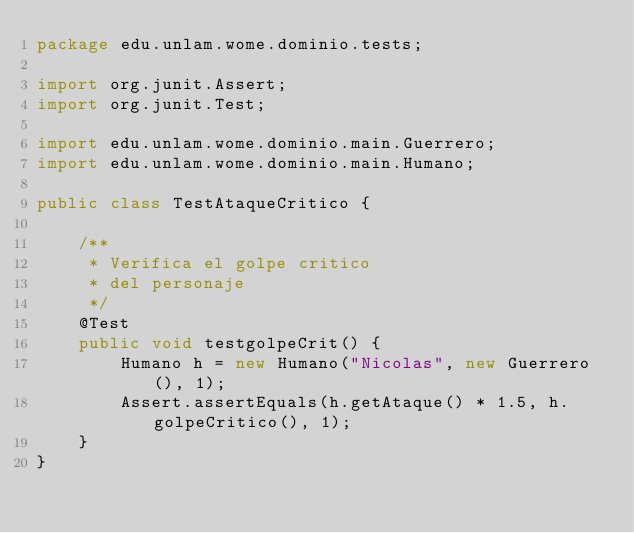<code> <loc_0><loc_0><loc_500><loc_500><_Java_>package edu.unlam.wome.dominio.tests;

import org.junit.Assert;
import org.junit.Test;

import edu.unlam.wome.dominio.main.Guerrero;
import edu.unlam.wome.dominio.main.Humano;

public class TestAtaqueCritico {

	/**
	 * Verifica el golpe critico
	 * del personaje
	 */
	@Test
	public void testgolpeCrit() {
		Humano h = new Humano("Nicolas", new Guerrero(), 1);
		Assert.assertEquals(h.getAtaque() * 1.5, h.golpeCritico(), 1);
	}
}
</code> 